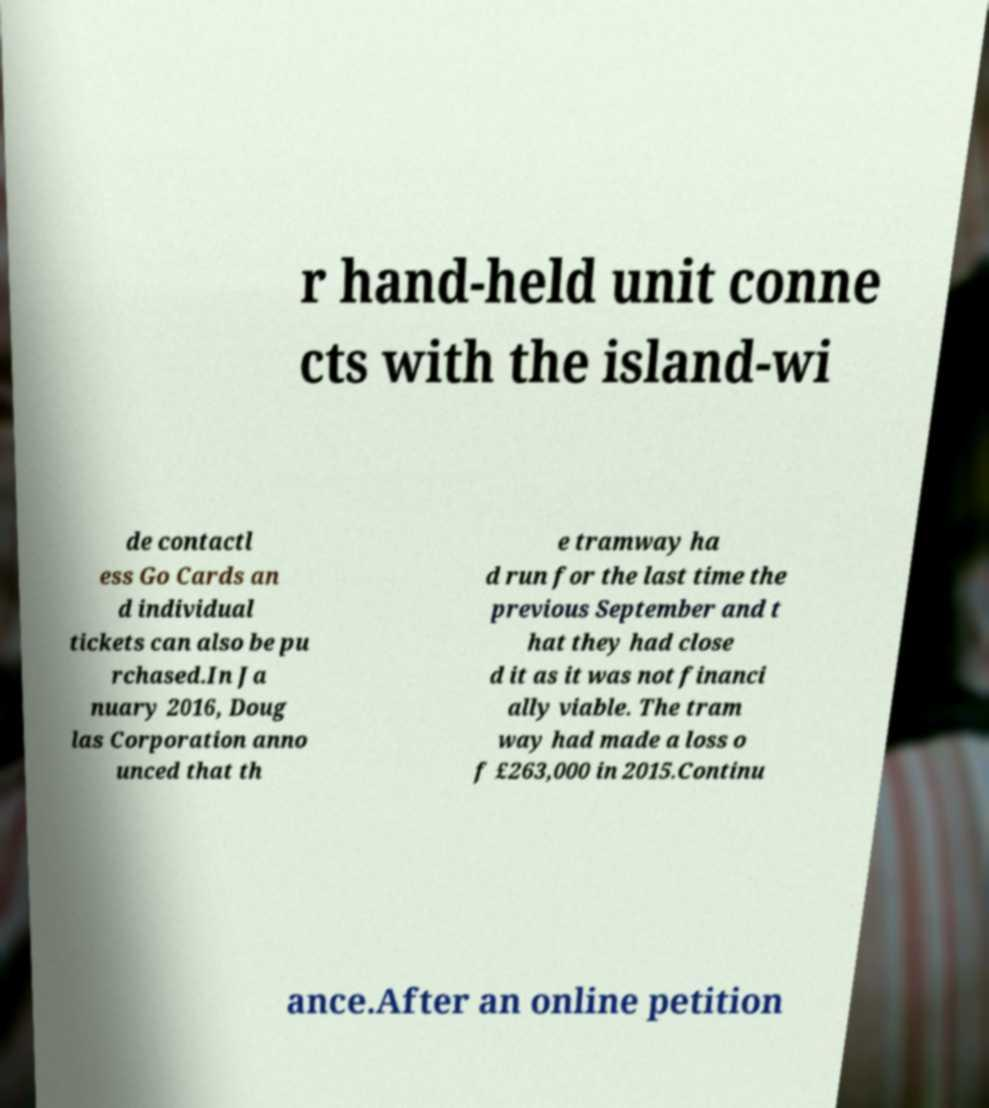I need the written content from this picture converted into text. Can you do that? r hand-held unit conne cts with the island-wi de contactl ess Go Cards an d individual tickets can also be pu rchased.In Ja nuary 2016, Doug las Corporation anno unced that th e tramway ha d run for the last time the previous September and t hat they had close d it as it was not financi ally viable. The tram way had made a loss o f £263,000 in 2015.Continu ance.After an online petition 